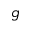Convert formula to latex. <formula><loc_0><loc_0><loc_500><loc_500>g</formula> 